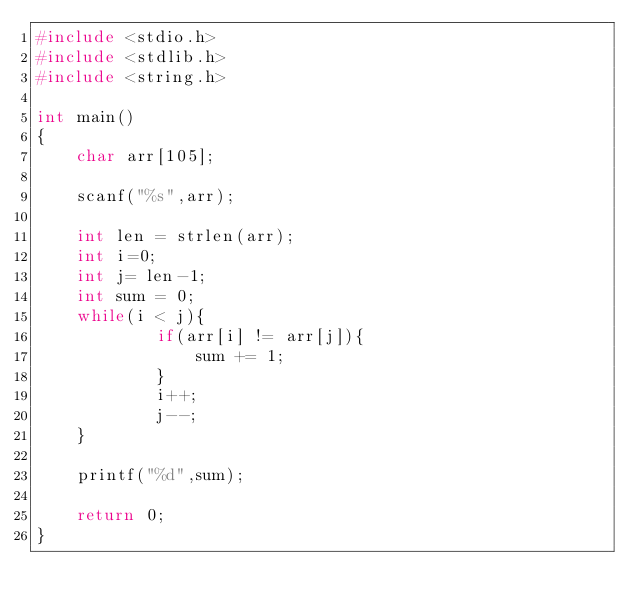Convert code to text. <code><loc_0><loc_0><loc_500><loc_500><_C_>#include <stdio.h>
#include <stdlib.h>
#include <string.h>

int main()
{
  	char arr[105];
  
  	scanf("%s",arr);
  
  	int len = strlen(arr);
  	int i=0;
  	int j= len-1;
  	int sum = 0;
  	while(i < j){
      		if(arr[i] != arr[j]){
              	sum += 1;
            }
            i++;
            j--;
    }
  	
  	printf("%d",sum);
  
  	return 0;
}
</code> 